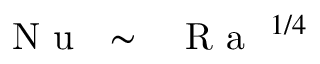<formula> <loc_0><loc_0><loc_500><loc_500>{ N u } \sim { R a } ^ { 1 / 4 }</formula> 